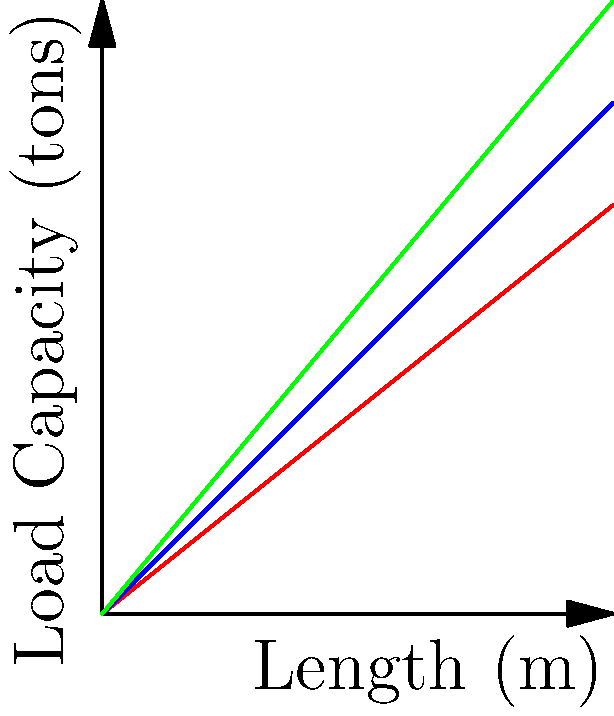As an architect with experience in modern design, you're tasked with selecting the most efficient beam design for a new bakery. Given the load-bearing capacity graph for three beam types (rectangular, I-beam, and truss) over various lengths, which beam design would you recommend for a 4-meter span that needs to support a load of at least 4 tons? To determine the most efficient beam design for the given requirements, let's analyze the graph step-by-step:

1. Identify the requirements:
   - Span length: 4 meters
   - Minimum load capacity: 4 tons

2. Examine each beam type at the 4-meter mark:
   a) Rectangular beam:
      At 4m, the load capacity is approximately 3.2 tons.
      $$3.2 \text{ tons} < 4 \text{ tons}$$
      This does not meet the minimum load requirement.

   b) I-beam:
      At 4m, the load capacity is exactly 4 tons.
      $$4 \text{ tons} = 4 \text{ tons}$$
      This meets the minimum load requirement.

   c) Truss:
      At 4m, the load capacity is approximately 4.8 tons.
      $$4.8 \text{ tons} > 4 \text{ tons}$$
      This exceeds the minimum load requirement.

3. Compare the viable options (I-beam and Truss):
   - The I-beam meets the minimum requirement exactly.
   - The Truss exceeds the minimum requirement by 0.8 tons.

4. Consider efficiency:
   While both the I-beam and Truss meet the load requirements, the Truss offers additional load capacity, which could be beneficial for future-proofing or accommodating unexpected loads.

5. Factor in modern design aesthetics:
   As an architect passionate about modern design, the clean lines of an I-beam might be more visually appealing in a modern bakery setting compared to a more industrial-looking truss.

Given these considerations, the I-beam presents the most balanced choice, meeting the load requirements while potentially offering a more sleek, modern appearance that aligns with contemporary bakery design trends.
Answer: I-beam 